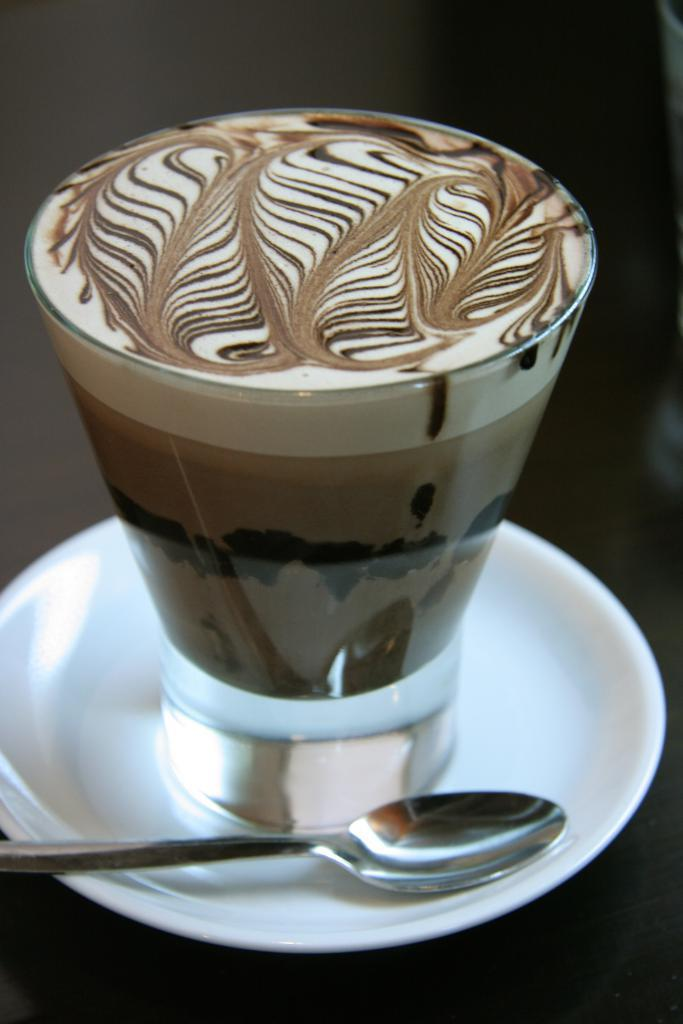What is in the glass that is visible in the image? There is a drink in the glass in the image. What other items can be seen in the image? There is a plate and a spoon visible in the image. What type of punishment is being served on the plate in the image? There is no punishment present in the image; it is a plate with an unspecified item on it. 